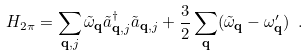Convert formula to latex. <formula><loc_0><loc_0><loc_500><loc_500>H _ { 2 \pi } = \sum _ { \mathbf q , j } \tilde { \omega } _ { \mathbf q } \tilde { a } ^ { \dagger } _ { \mathbf q , j } \tilde { a } _ { \mathbf q , j } + \frac { 3 } { 2 } \sum _ { \mathbf q } ( \tilde { \omega } _ { \mathbf q } - \omega ^ { \prime } _ { \mathbf q } ) \ .</formula> 